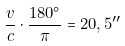Convert formula to latex. <formula><loc_0><loc_0><loc_500><loc_500>\frac { v } { c } \cdot \frac { 1 8 0 ^ { \circ } } { \pi } = 2 0 , 5 ^ { \prime \prime }</formula> 